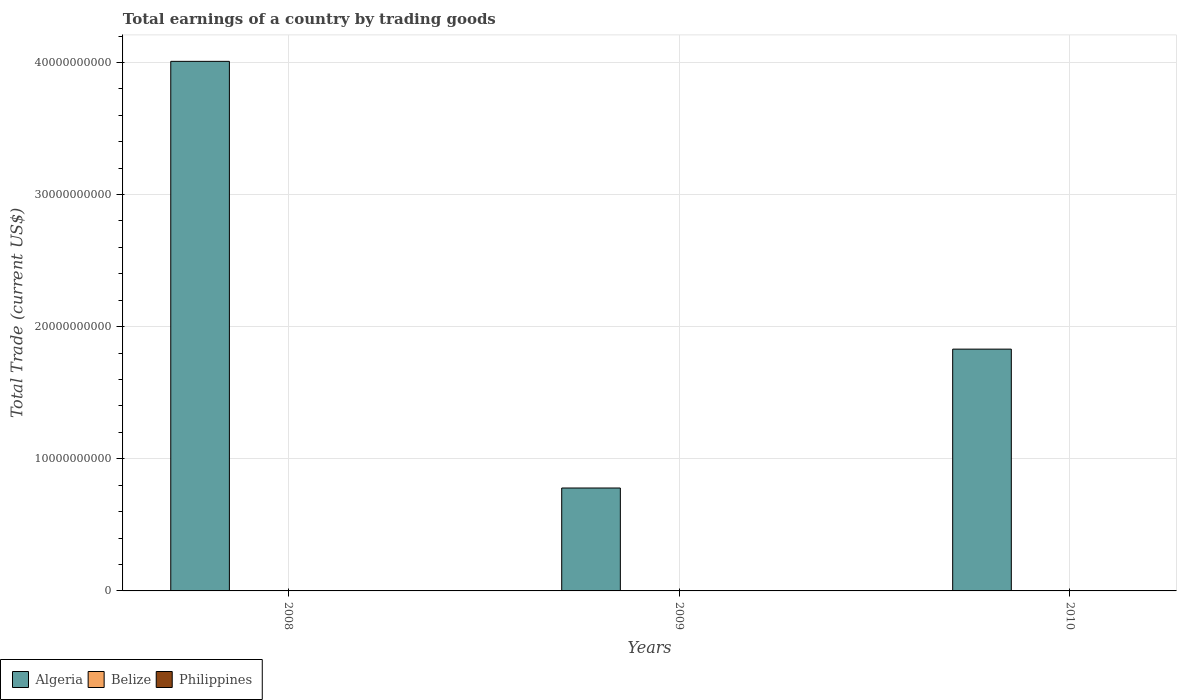Are the number of bars per tick equal to the number of legend labels?
Provide a succinct answer. No. What is the total earnings in Belize in 2010?
Give a very brief answer. 0. Across all years, what is the maximum total earnings in Algeria?
Make the answer very short. 4.01e+1. Across all years, what is the minimum total earnings in Algeria?
Offer a terse response. 7.79e+09. In which year was the total earnings in Algeria maximum?
Make the answer very short. 2008. What is the difference between the total earnings in Algeria in 2009 and that in 2010?
Your answer should be compact. -1.05e+1. What is the difference between the total earnings in Algeria in 2010 and the total earnings in Philippines in 2009?
Provide a short and direct response. 1.83e+1. What is the average total earnings in Philippines per year?
Give a very brief answer. 0. In how many years, is the total earnings in Algeria greater than 10000000000 US$?
Provide a succinct answer. 2. What is the ratio of the total earnings in Algeria in 2008 to that in 2010?
Provide a short and direct response. 2.19. What is the difference between the highest and the second highest total earnings in Algeria?
Offer a very short reply. 2.18e+1. What is the difference between the highest and the lowest total earnings in Algeria?
Keep it short and to the point. 3.23e+1. In how many years, is the total earnings in Belize greater than the average total earnings in Belize taken over all years?
Your answer should be very brief. 0. Is the sum of the total earnings in Algeria in 2008 and 2009 greater than the maximum total earnings in Philippines across all years?
Your answer should be very brief. Yes. Is it the case that in every year, the sum of the total earnings in Algeria and total earnings in Philippines is greater than the total earnings in Belize?
Ensure brevity in your answer.  Yes. How many bars are there?
Keep it short and to the point. 3. How many years are there in the graph?
Provide a succinct answer. 3. Are the values on the major ticks of Y-axis written in scientific E-notation?
Provide a short and direct response. No. Does the graph contain grids?
Ensure brevity in your answer.  Yes. Where does the legend appear in the graph?
Provide a short and direct response. Bottom left. What is the title of the graph?
Your answer should be very brief. Total earnings of a country by trading goods. What is the label or title of the X-axis?
Your answer should be compact. Years. What is the label or title of the Y-axis?
Provide a succinct answer. Total Trade (current US$). What is the Total Trade (current US$) of Algeria in 2008?
Keep it short and to the point. 4.01e+1. What is the Total Trade (current US$) in Algeria in 2009?
Provide a short and direct response. 7.79e+09. What is the Total Trade (current US$) in Belize in 2009?
Give a very brief answer. 0. What is the Total Trade (current US$) in Algeria in 2010?
Provide a succinct answer. 1.83e+1. What is the Total Trade (current US$) in Belize in 2010?
Offer a terse response. 0. What is the Total Trade (current US$) in Philippines in 2010?
Ensure brevity in your answer.  0. Across all years, what is the maximum Total Trade (current US$) in Algeria?
Provide a succinct answer. 4.01e+1. Across all years, what is the minimum Total Trade (current US$) in Algeria?
Make the answer very short. 7.79e+09. What is the total Total Trade (current US$) of Algeria in the graph?
Offer a terse response. 6.62e+1. What is the total Total Trade (current US$) of Belize in the graph?
Give a very brief answer. 0. What is the difference between the Total Trade (current US$) in Algeria in 2008 and that in 2009?
Offer a terse response. 3.23e+1. What is the difference between the Total Trade (current US$) in Algeria in 2008 and that in 2010?
Provide a short and direct response. 2.18e+1. What is the difference between the Total Trade (current US$) in Algeria in 2009 and that in 2010?
Offer a terse response. -1.05e+1. What is the average Total Trade (current US$) in Algeria per year?
Make the answer very short. 2.21e+1. What is the average Total Trade (current US$) of Belize per year?
Your response must be concise. 0. What is the average Total Trade (current US$) in Philippines per year?
Give a very brief answer. 0. What is the ratio of the Total Trade (current US$) of Algeria in 2008 to that in 2009?
Keep it short and to the point. 5.15. What is the ratio of the Total Trade (current US$) of Algeria in 2008 to that in 2010?
Provide a succinct answer. 2.19. What is the ratio of the Total Trade (current US$) of Algeria in 2009 to that in 2010?
Your response must be concise. 0.43. What is the difference between the highest and the second highest Total Trade (current US$) of Algeria?
Ensure brevity in your answer.  2.18e+1. What is the difference between the highest and the lowest Total Trade (current US$) of Algeria?
Provide a succinct answer. 3.23e+1. 